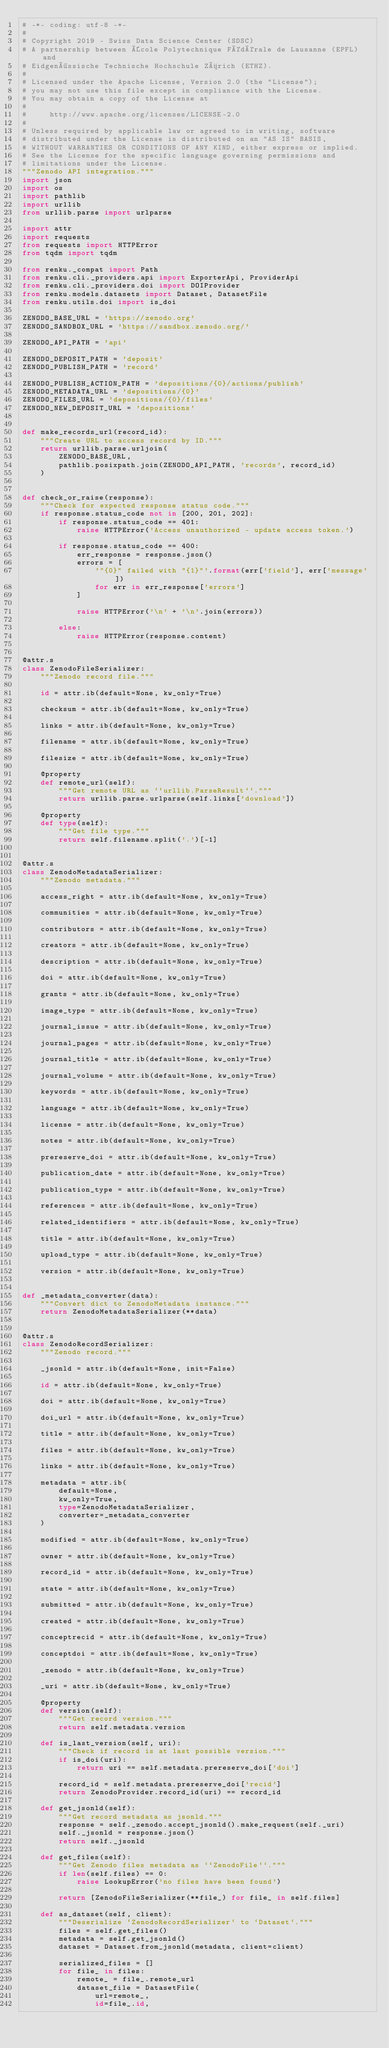<code> <loc_0><loc_0><loc_500><loc_500><_Python_># -*- coding: utf-8 -*-
#
# Copyright 2019 - Swiss Data Science Center (SDSC)
# A partnership between École Polytechnique Fédérale de Lausanne (EPFL) and
# Eidgenössische Technische Hochschule Zürich (ETHZ).
#
# Licensed under the Apache License, Version 2.0 (the "License");
# you may not use this file except in compliance with the License.
# You may obtain a copy of the License at
#
#     http://www.apache.org/licenses/LICENSE-2.0
#
# Unless required by applicable law or agreed to in writing, software
# distributed under the License is distributed on an "AS IS" BASIS,
# WITHOUT WARRANTIES OR CONDITIONS OF ANY KIND, either express or implied.
# See the License for the specific language governing permissions and
# limitations under the License.
"""Zenodo API integration."""
import json
import os
import pathlib
import urllib
from urllib.parse import urlparse

import attr
import requests
from requests import HTTPError
from tqdm import tqdm

from renku._compat import Path
from renku.cli._providers.api import ExporterApi, ProviderApi
from renku.cli._providers.doi import DOIProvider
from renku.models.datasets import Dataset, DatasetFile
from renku.utils.doi import is_doi

ZENODO_BASE_URL = 'https://zenodo.org'
ZENODO_SANDBOX_URL = 'https://sandbox.zenodo.org/'

ZENODO_API_PATH = 'api'

ZENODO_DEPOSIT_PATH = 'deposit'
ZENODO_PUBLISH_PATH = 'record'

ZENODO_PUBLISH_ACTION_PATH = 'depositions/{0}/actions/publish'
ZENODO_METADATA_URL = 'depositions/{0}'
ZENODO_FILES_URL = 'depositions/{0}/files'
ZENODO_NEW_DEPOSIT_URL = 'depositions'


def make_records_url(record_id):
    """Create URL to access record by ID."""
    return urllib.parse.urljoin(
        ZENODO_BASE_URL,
        pathlib.posixpath.join(ZENODO_API_PATH, 'records', record_id)
    )


def check_or_raise(response):
    """Check for expected response status code."""
    if response.status_code not in [200, 201, 202]:
        if response.status_code == 401:
            raise HTTPError('Access unauthorized - update access token.')

        if response.status_code == 400:
            err_response = response.json()
            errors = [
                '"{0}" failed with "{1}"'.format(err['field'], err['message'])
                for err in err_response['errors']
            ]

            raise HTTPError('\n' + '\n'.join(errors))

        else:
            raise HTTPError(response.content)


@attr.s
class ZenodoFileSerializer:
    """Zenodo record file."""

    id = attr.ib(default=None, kw_only=True)

    checksum = attr.ib(default=None, kw_only=True)

    links = attr.ib(default=None, kw_only=True)

    filename = attr.ib(default=None, kw_only=True)

    filesize = attr.ib(default=None, kw_only=True)

    @property
    def remote_url(self):
        """Get remote URL as ``urllib.ParseResult``."""
        return urllib.parse.urlparse(self.links['download'])

    @property
    def type(self):
        """Get file type."""
        return self.filename.split('.')[-1]


@attr.s
class ZenodoMetadataSerializer:
    """Zenodo metadata."""

    access_right = attr.ib(default=None, kw_only=True)

    communities = attr.ib(default=None, kw_only=True)

    contributors = attr.ib(default=None, kw_only=True)

    creators = attr.ib(default=None, kw_only=True)

    description = attr.ib(default=None, kw_only=True)

    doi = attr.ib(default=None, kw_only=True)

    grants = attr.ib(default=None, kw_only=True)

    image_type = attr.ib(default=None, kw_only=True)

    journal_issue = attr.ib(default=None, kw_only=True)

    journal_pages = attr.ib(default=None, kw_only=True)

    journal_title = attr.ib(default=None, kw_only=True)

    journal_volume = attr.ib(default=None, kw_only=True)

    keywords = attr.ib(default=None, kw_only=True)

    language = attr.ib(default=None, kw_only=True)

    license = attr.ib(default=None, kw_only=True)

    notes = attr.ib(default=None, kw_only=True)

    prereserve_doi = attr.ib(default=None, kw_only=True)

    publication_date = attr.ib(default=None, kw_only=True)

    publication_type = attr.ib(default=None, kw_only=True)

    references = attr.ib(default=None, kw_only=True)

    related_identifiers = attr.ib(default=None, kw_only=True)

    title = attr.ib(default=None, kw_only=True)

    upload_type = attr.ib(default=None, kw_only=True)

    version = attr.ib(default=None, kw_only=True)


def _metadata_converter(data):
    """Convert dict to ZenodoMetadata instance."""
    return ZenodoMetadataSerializer(**data)


@attr.s
class ZenodoRecordSerializer:
    """Zenodo record."""

    _jsonld = attr.ib(default=None, init=False)

    id = attr.ib(default=None, kw_only=True)

    doi = attr.ib(default=None, kw_only=True)

    doi_url = attr.ib(default=None, kw_only=True)

    title = attr.ib(default=None, kw_only=True)

    files = attr.ib(default=None, kw_only=True)

    links = attr.ib(default=None, kw_only=True)

    metadata = attr.ib(
        default=None,
        kw_only=True,
        type=ZenodoMetadataSerializer,
        converter=_metadata_converter
    )

    modified = attr.ib(default=None, kw_only=True)

    owner = attr.ib(default=None, kw_only=True)

    record_id = attr.ib(default=None, kw_only=True)

    state = attr.ib(default=None, kw_only=True)

    submitted = attr.ib(default=None, kw_only=True)

    created = attr.ib(default=None, kw_only=True)

    conceptrecid = attr.ib(default=None, kw_only=True)

    conceptdoi = attr.ib(default=None, kw_only=True)

    _zenodo = attr.ib(default=None, kw_only=True)

    _uri = attr.ib(default=None, kw_only=True)

    @property
    def version(self):
        """Get record version."""
        return self.metadata.version

    def is_last_version(self, uri):
        """Check if record is at last possible version."""
        if is_doi(uri):
            return uri == self.metadata.prereserve_doi['doi']

        record_id = self.metadata.prereserve_doi['recid']
        return ZenodoProvider.record_id(uri) == record_id

    def get_jsonld(self):
        """Get record metadata as jsonld."""
        response = self._zenodo.accept_jsonld().make_request(self._uri)
        self._jsonld = response.json()
        return self._jsonld

    def get_files(self):
        """Get Zenodo files metadata as ``ZenodoFile``."""
        if len(self.files) == 0:
            raise LookupError('no files have been found')

        return [ZenodoFileSerializer(**file_) for file_ in self.files]

    def as_dataset(self, client):
        """Deserialize `ZenodoRecordSerializer` to `Dataset`."""
        files = self.get_files()
        metadata = self.get_jsonld()
        dataset = Dataset.from_jsonld(metadata, client=client)

        serialized_files = []
        for file_ in files:
            remote_ = file_.remote_url
            dataset_file = DatasetFile(
                url=remote_,
                id=file_.id,</code> 